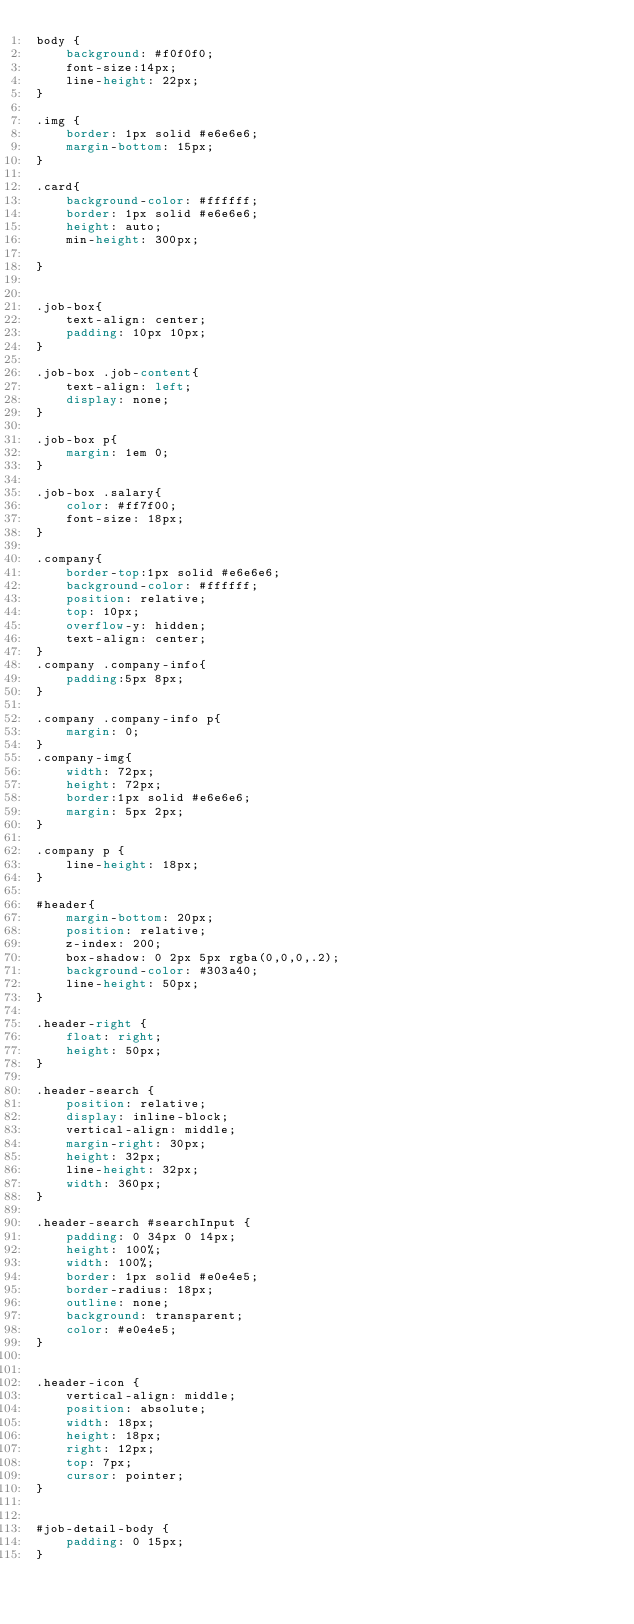Convert code to text. <code><loc_0><loc_0><loc_500><loc_500><_CSS_>body {
    background: #f0f0f0;
    font-size:14px;
    line-height: 22px;
}

.img {
    border: 1px solid #e6e6e6;
    margin-bottom: 15px;
}

.card{
    background-color: #ffffff;
    border: 1px solid #e6e6e6;
    height: auto;
    min-height: 300px;

}


.job-box{
    text-align: center;
    padding: 10px 10px;
}

.job-box .job-content{
    text-align: left;
    display: none;
}

.job-box p{
    margin: 1em 0;
}

.job-box .salary{
    color: #ff7f00;
    font-size: 18px;
}

.company{
    border-top:1px solid #e6e6e6;
    background-color: #ffffff;
    position: relative;
    top: 10px;
    overflow-y: hidden;
    text-align: center;
}
.company .company-info{
    padding:5px 8px;
}

.company .company-info p{
    margin: 0;
}
.company-img{
    width: 72px;
    height: 72px;
    border:1px solid #e6e6e6;
    margin: 5px 2px;
}

.company p {
    line-height: 18px;
}

#header{
    margin-bottom: 20px;
    position: relative;
    z-index: 200;
    box-shadow: 0 2px 5px rgba(0,0,0,.2);
    background-color: #303a40;
    line-height: 50px;
}

.header-right {
    float: right;
    height: 50px;
}

.header-search {
    position: relative;
    display: inline-block;
    vertical-align: middle;
    margin-right: 30px;
    height: 32px;
    line-height: 32px;
    width: 360px;
}

.header-search #searchInput {
    padding: 0 34px 0 14px;
    height: 100%;
    width: 100%;
    border: 1px solid #e0e4e5;
    border-radius: 18px;
    outline: none;
    background: transparent;
    color: #e0e4e5;
}


.header-icon {
    vertical-align: middle;
    position: absolute;
    width: 18px;
    height: 18px;
    right: 12px;
    top: 7px;
    cursor: pointer;
}


#job-detail-body {
    padding: 0 15px;
}

</code> 